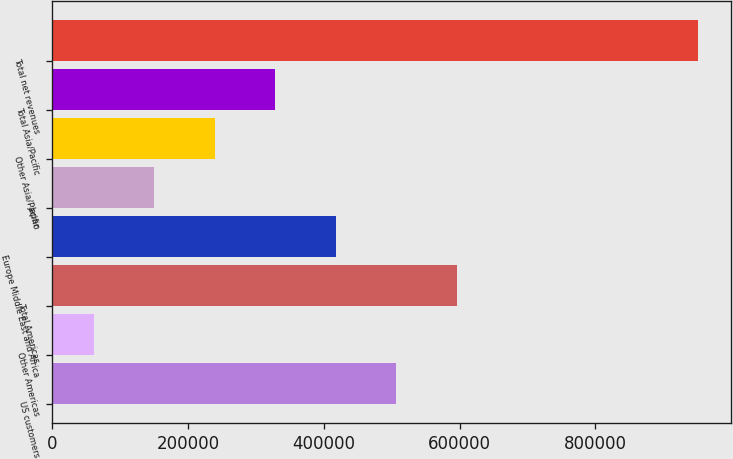Convert chart. <chart><loc_0><loc_0><loc_500><loc_500><bar_chart><fcel>US customers<fcel>Other Americas<fcel>Total Americas<fcel>Europe Middle East and Africa<fcel>Japan<fcel>Other Asia/Pacific<fcel>Total Asia/Pacific<fcel>Total net revenues<nl><fcel>506279<fcel>60915<fcel>595352<fcel>417206<fcel>149988<fcel>239061<fcel>328133<fcel>951643<nl></chart> 